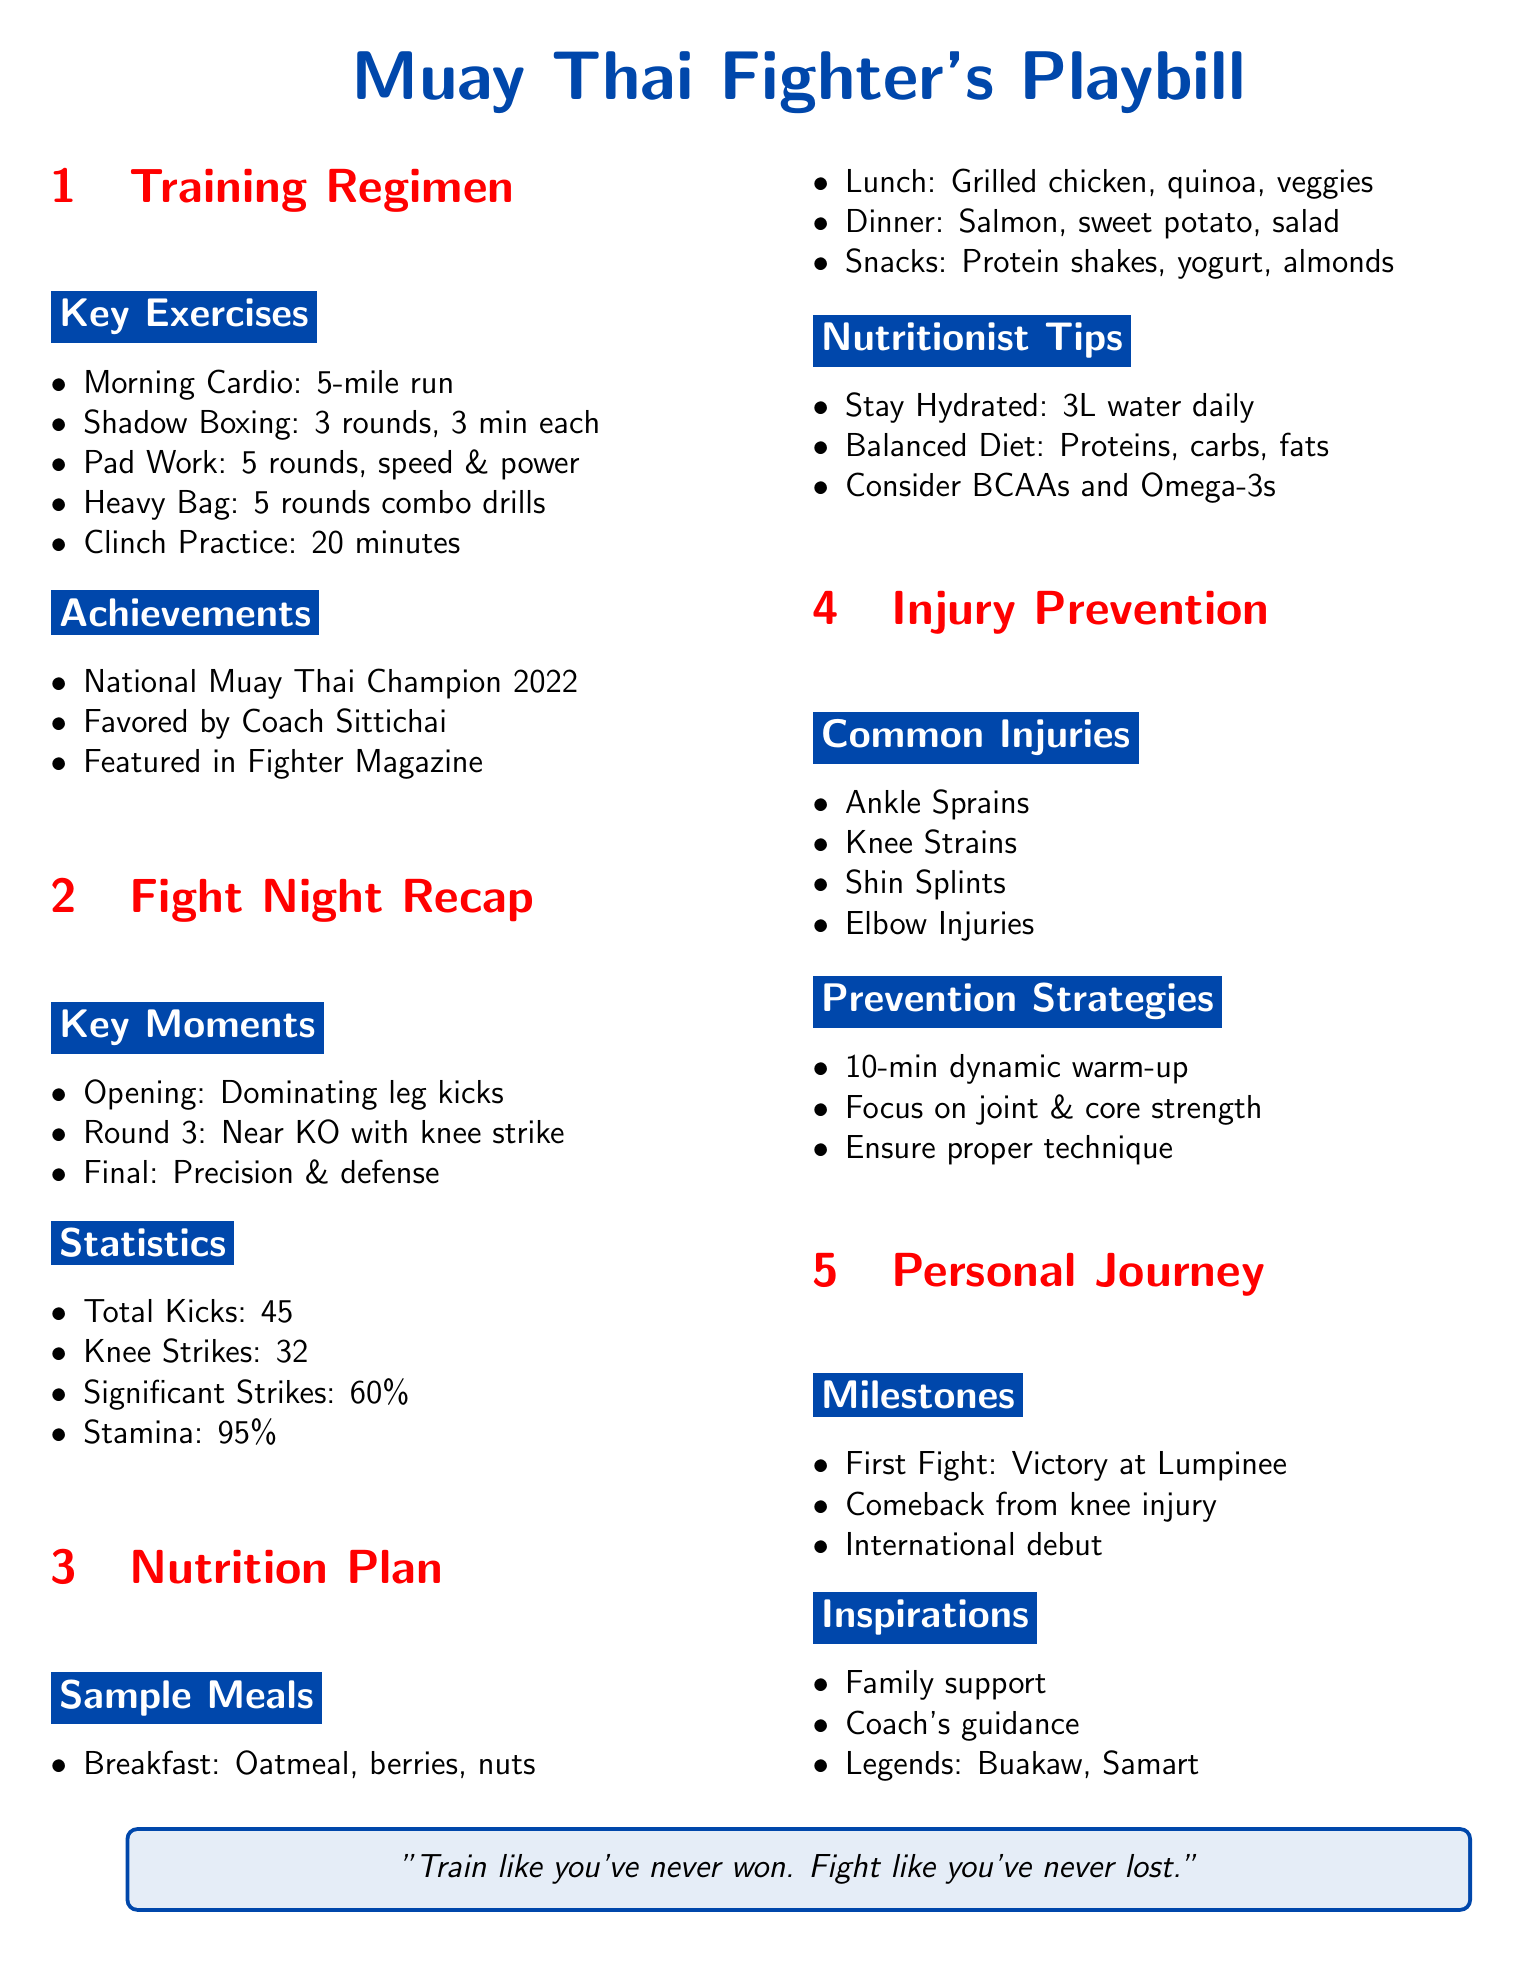what is the name of the champion title won in 2022? The document clearly mentions the achievement of being the National Muay Thai Champion in 2022.
Answer: National Muay Thai Champion 2022 how many total kicks were landed during the fight night? The fight statistics section states that a total of 45 kicks were landed.
Answer: 45 what is the hydration recommendation from nutritionists? The nutritionist tips specify that staying hydrated means 3 liters of water daily.
Answer: 3L water daily name one of the common injuries in Muay Thai mentioned in the document. The document lists common injuries, such as ankle sprains, knee strains, shin splints, and elbow injuries.
Answer: Ankle Sprains how long is the morning cardio run? The training regimen specifies that the morning cardio run is 5 miles long.
Answer: 5-mile run what did the fighter achieve after their comeback? The document states that the fighter made a comeback from a knee injury and mentions this as a milestone.
Answer: Comeback from knee injury who is notable for supporting the fighter on their journey? The inspirations section highlights family support as a key motivational factor.
Answer: Family support how many rounds of shadow boxing are included in the training regimen? The training regimen indicates that there are 3 rounds of shadow boxing, each lasting 3 minutes.
Answer: 3 rounds, 3 min each 